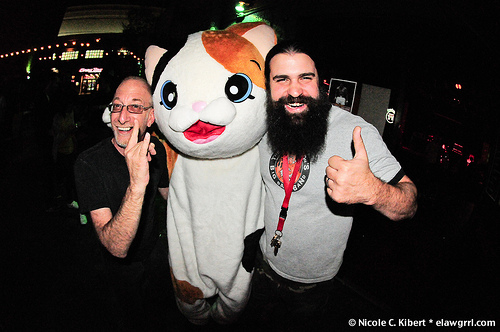<image>
Can you confirm if the man is behind the costume? No. The man is not behind the costume. From this viewpoint, the man appears to be positioned elsewhere in the scene. 